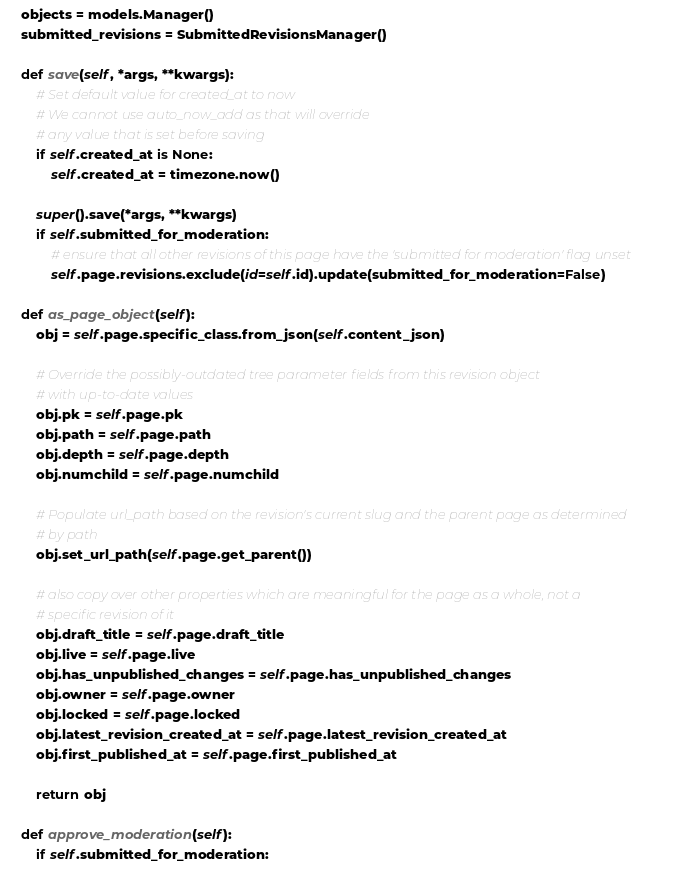Convert code to text. <code><loc_0><loc_0><loc_500><loc_500><_Python_>
    objects = models.Manager()
    submitted_revisions = SubmittedRevisionsManager()

    def save(self, *args, **kwargs):
        # Set default value for created_at to now
        # We cannot use auto_now_add as that will override
        # any value that is set before saving
        if self.created_at is None:
            self.created_at = timezone.now()

        super().save(*args, **kwargs)
        if self.submitted_for_moderation:
            # ensure that all other revisions of this page have the 'submitted for moderation' flag unset
            self.page.revisions.exclude(id=self.id).update(submitted_for_moderation=False)

    def as_page_object(self):
        obj = self.page.specific_class.from_json(self.content_json)

        # Override the possibly-outdated tree parameter fields from this revision object
        # with up-to-date values
        obj.pk = self.page.pk
        obj.path = self.page.path
        obj.depth = self.page.depth
        obj.numchild = self.page.numchild

        # Populate url_path based on the revision's current slug and the parent page as determined
        # by path
        obj.set_url_path(self.page.get_parent())

        # also copy over other properties which are meaningful for the page as a whole, not a
        # specific revision of it
        obj.draft_title = self.page.draft_title
        obj.live = self.page.live
        obj.has_unpublished_changes = self.page.has_unpublished_changes
        obj.owner = self.page.owner
        obj.locked = self.page.locked
        obj.latest_revision_created_at = self.page.latest_revision_created_at
        obj.first_published_at = self.page.first_published_at

        return obj

    def approve_moderation(self):
        if self.submitted_for_moderation:</code> 